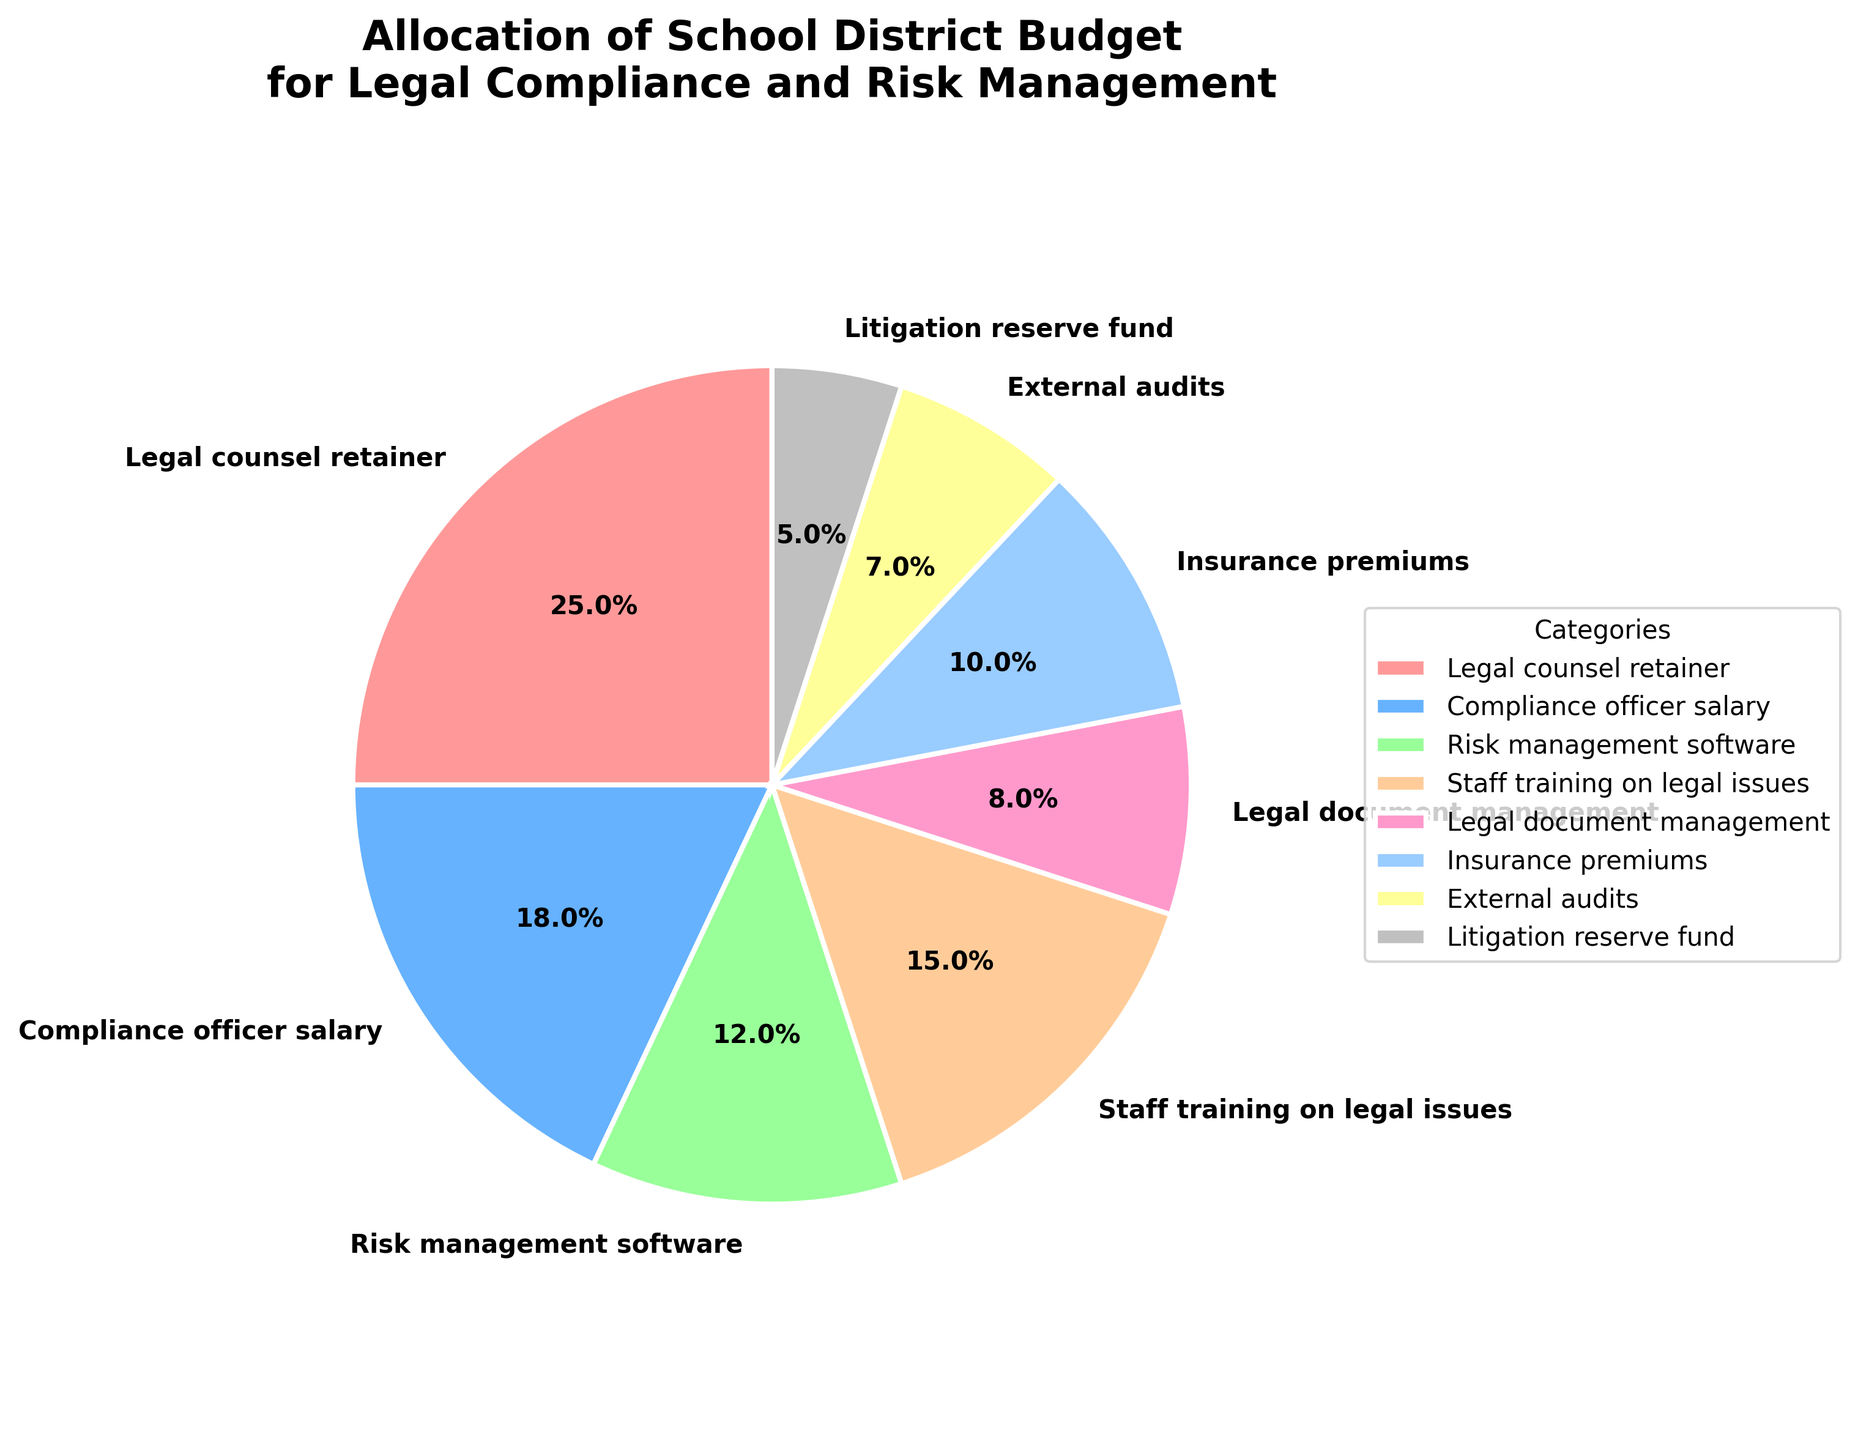which category has the largest percentage? The category with the largest percentage can be determined by looking at the category with the largest wedge visually in the pie chart. Here, the largest wedge corresponds to the "Legal counsel retainer"
Answer: Legal counsel retainer Which two categories combined account for more than half of the budget? To find the categories that together account for more than 50% of the budget, look at the two largest percentages in the pie chart. "Legal counsel retainer" is 25% and "Compliance officer salary" is 18%. Together they account for 25% + 18% = 43%. Adding the third largest "Staff training on legal issues" which is 15% gives a total of 43% + 15% = 58%. Thus, "Legal counsel retainer" and "Staff training on legal issues" account for more than half.
Answer: Legal counsel retainer, Staff training on legal issues Which category has the smallest allocation? The smallest wedge in the pie chart represents the category with the smallest percentage. Here, it corresponds to the "Litigation reserve fund"
Answer: Litigation reserve fund What is the difference in percentage between the compliance officer salary and insurance premiums? The compliance officer salary is 18%, and insurance premiums are 10%. Subtracting these gives 18% - 10% = 8%
Answer: 8% What is the combined percentage of insurance premiums, risk management software, and external audits? Summing up the percentages for insurance premiums (10%), risk management software (12%), and external audits (7%) gives 10% + 12% + 7% = 29%
Answer: 29% How does the percentage allocated to staff training on legal issues compare to the percentage for risk management software? Comparing their respective percentages, staff training on legal issues is 15%, and risk management software is 12%. 15% is greater than 12%.
Answer: Staff training on legal issues is greater than risk management software Which categories use more than 10% of the budget? To determine all categories that use more than 10% of the budget, look for wedges larger than 10%. The categories are: Legal counsel retainer (25%), Compliance officer salary (18%), Staff training on legal issues (15%), and Risk management software (12%)
Answer: Legal counsel retainer, Compliance officer salary, Staff training on legal issues, Risk management software is the allocation for external audits and litigation reserve fund combined more than 10%? The percentages for external audits (7%) and litigation reserve fund (5%) when combined are 7% + 5% = 12%. Since 12% is greater than 10%, the answer is yes.
Answer: Yes 